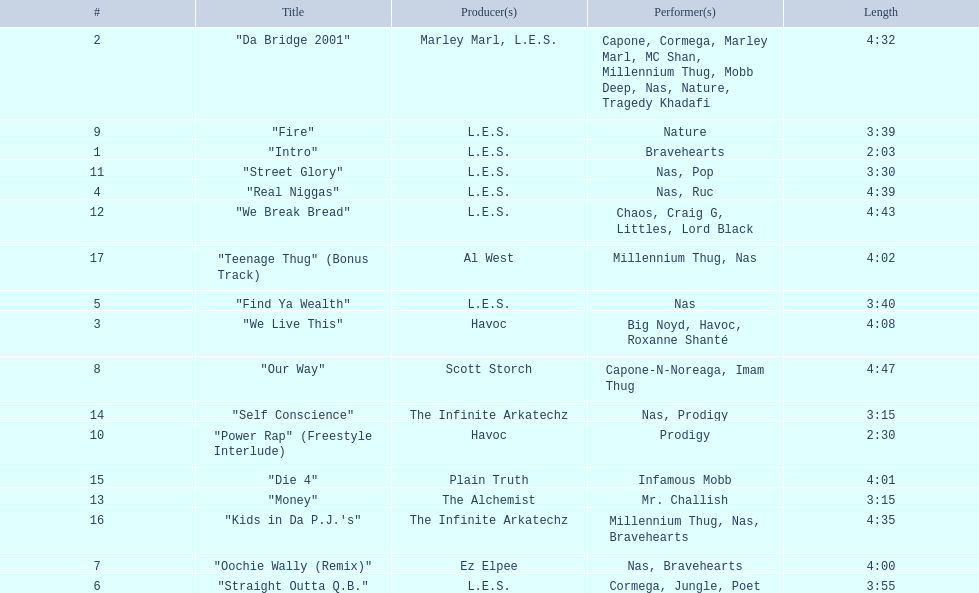What are the track times on the nas & ill will records presents qb's finest album? 2:03, 4:32, 4:08, 4:39, 3:40, 3:55, 4:00, 4:47, 3:39, 2:30, 3:30, 4:43, 3:15, 3:15, 4:01, 4:35, 4:02. Of those which is the longest? 4:47. 